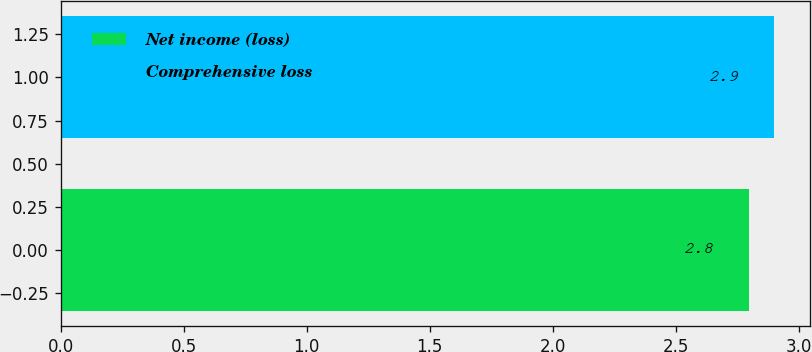Convert chart to OTSL. <chart><loc_0><loc_0><loc_500><loc_500><bar_chart><fcel>Net income (loss)<fcel>Comprehensive loss<nl><fcel>2.8<fcel>2.9<nl></chart> 